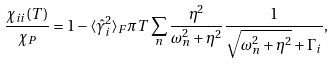<formula> <loc_0><loc_0><loc_500><loc_500>\frac { \chi _ { i i } ( T ) } { \chi _ { P } } = 1 - \langle \hat { \gamma } _ { i } ^ { 2 } \rangle _ { F } \pi T \sum _ { n } \frac { \eta ^ { 2 } } { \omega _ { n } ^ { 2 } + \eta ^ { 2 } } \frac { 1 } { \sqrt { \omega _ { n } ^ { 2 } + \eta ^ { 2 } } + \Gamma _ { i } } ,</formula> 